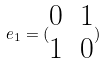<formula> <loc_0><loc_0><loc_500><loc_500>e _ { 1 } = ( \begin{matrix} 0 & 1 \\ 1 & 0 \end{matrix} )</formula> 